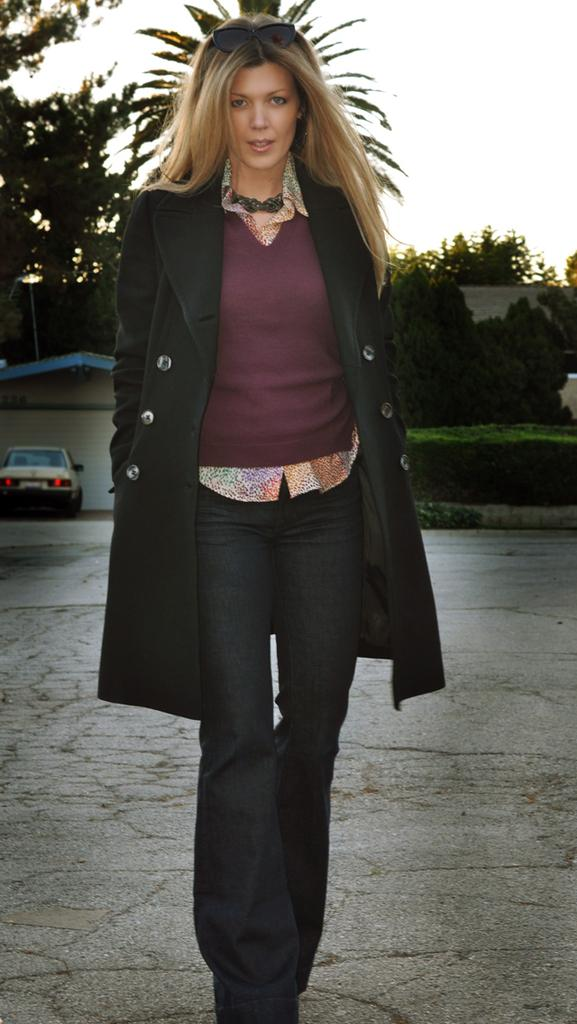What is the main subject of the image? There is a woman standing in the image. Can you describe what the woman is wearing? The woman is wearing clothes and goggles. What else can be seen in the image besides the woman? There is a vehicle, a footpath, a plant, trees, a building, and the sky visible in the image. What color is the tent in the image? There is no tent present in the image. How is the woman using the hammer in the image? There is no hammer present in the image. 